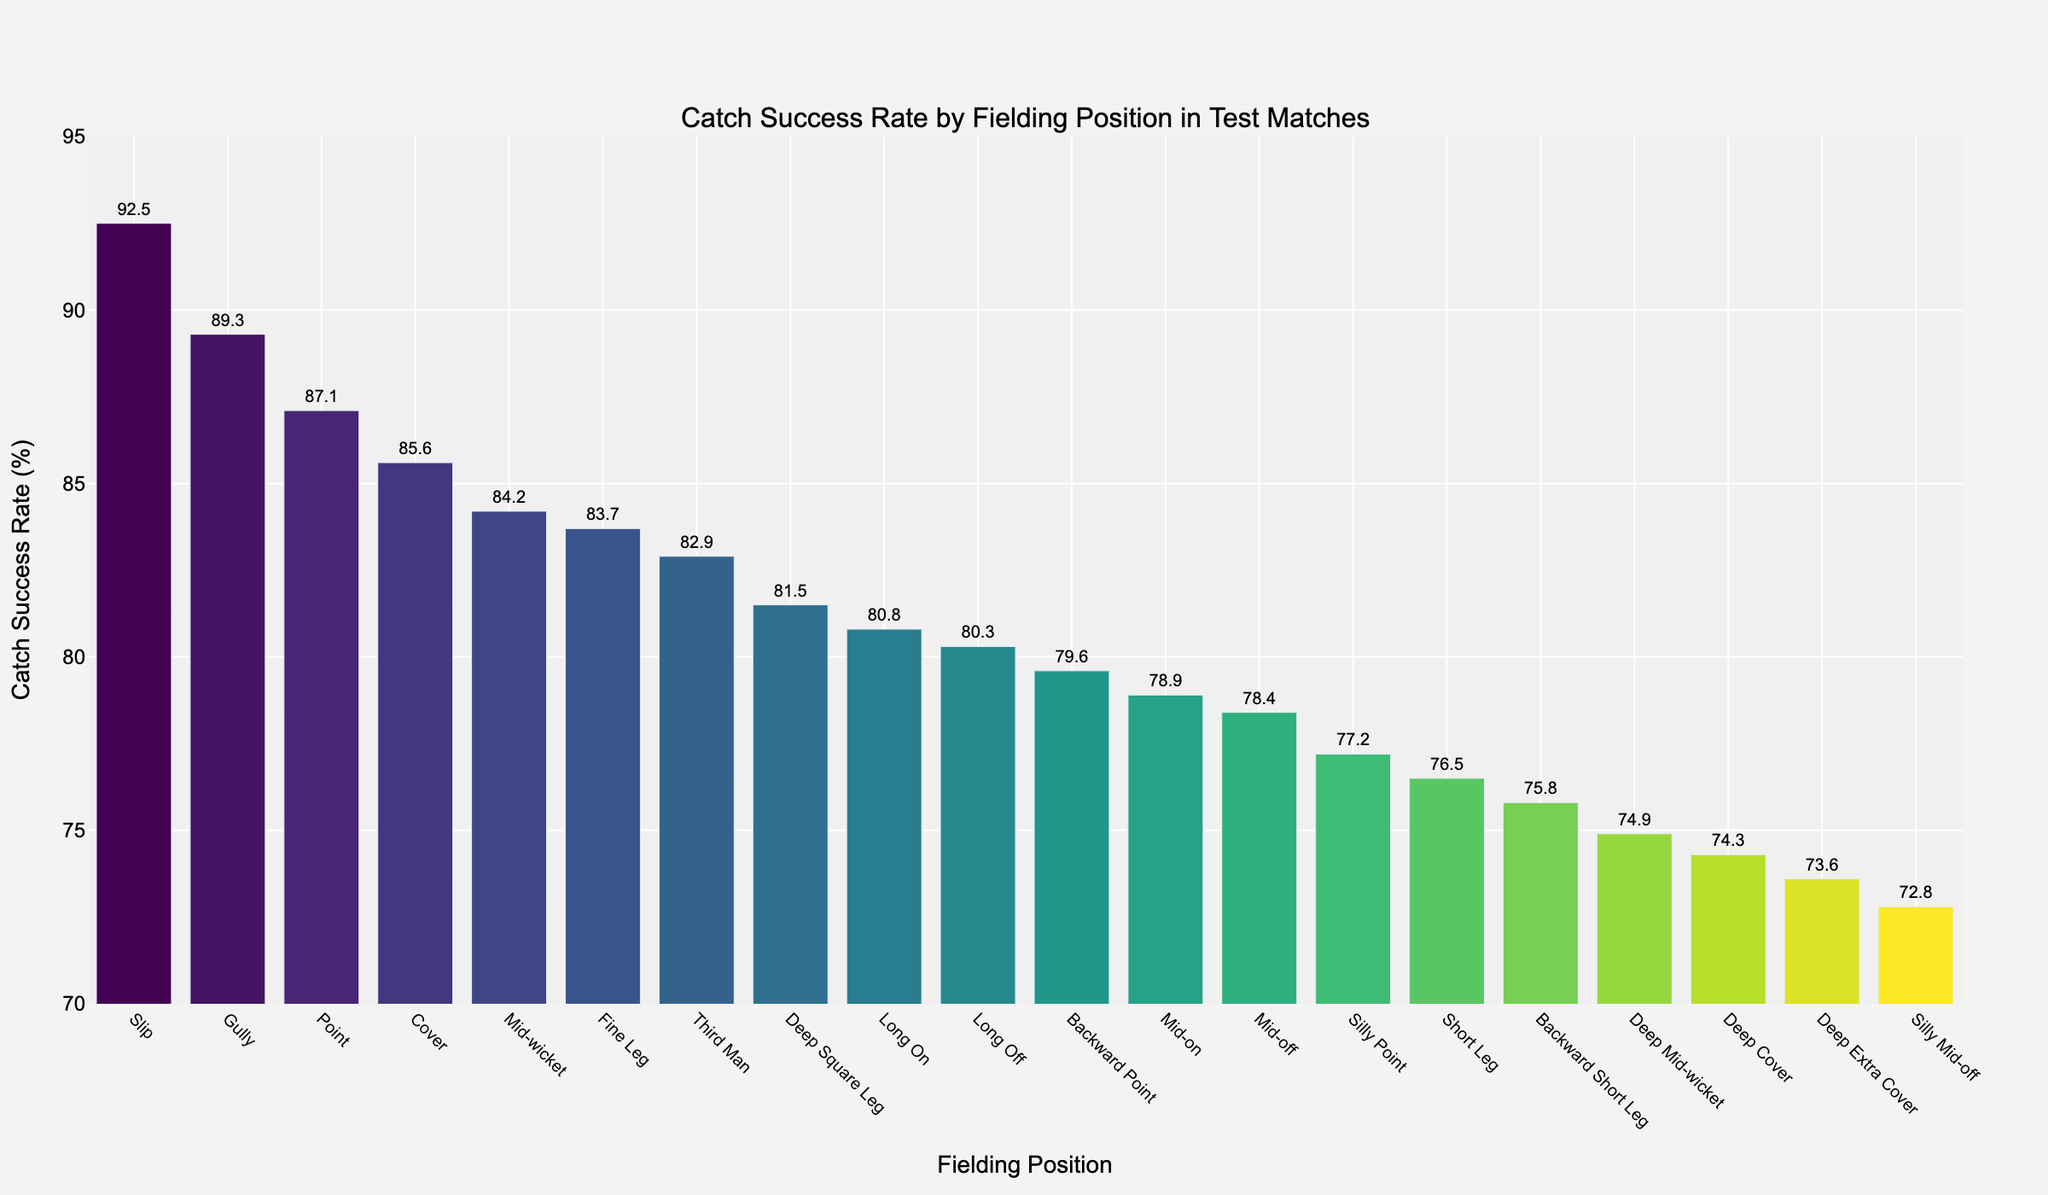Which fielding position has the highest catch success rate? The highest bar represents the fielding position 'Slip' with a catch success rate of 92.5%.
Answer: Slip What is the catch success rate for the 'Gully' position, and how does it compare to the 'Point' position? The 'Gully' position has a catch success rate of 89.3%, and the 'Point' position has a rate of 87.1%. The 'Gully' position has a higher catch success rate.
Answer: Gully has a higher catch success rate Which fielding position has a catch success rate closest to 80%? The 'Long On' position has a catch success rate of 80.8%, which is closest to 80%.
Answer: Long On What is the difference in catch success rate between 'Mid-wicket' and 'Fine Leg'? The catch success rate for 'Mid-wicket' is 84.2%, and for 'Fine Leg,' it is 83.7%. The difference is 84.2% - 83.7% = 0.5%.
Answer: 0.5% What is the average catch success rate for the positions 'Slip,' 'Gully,' and 'Point'? The catch success rates are 92.5%, 89.3%, and 87.1%, respectively. The average is (92.5 + 89.3 + 87.1) / 3 = 89.63%.
Answer: 89.63% Which positions have catch success rates higher than 90%? The bar representing 'Slip' shows a catch success rate of 92.5%, which is higher than 90%. No other fielding positions have a rate above 90%.
Answer: Slip How does the catch success rate of 'Mid-off' compare to 'Mid-on'? The 'Mid-off' position has a catch success rate of 78.4%, while 'Mid-on' has a rate of 78.9%. 'Mid-on' is slightly higher.
Answer: Mid-on is higher Among all positions, which has the lowest catch success rate? The lowest bar represents the 'Silly Mid-off' position with a catch success rate of 72.8%.
Answer: Silly Mid-off If you were to combine the catch success rates of 'Cover' and 'Point', what would be the total percentage? The catch success rates for 'Cover' and 'Point' are 85.6% and 87.1%, respectively. The total is 85.6% + 87.1% = 172.7%.
Answer: 172.7% To which category does the 'Short Leg' belong if grouped by positions with a catch success rate above or below 80%? The 'Short Leg' position has a catch success rate of 76.5%, which is below 80%.
Answer: Below 80% 